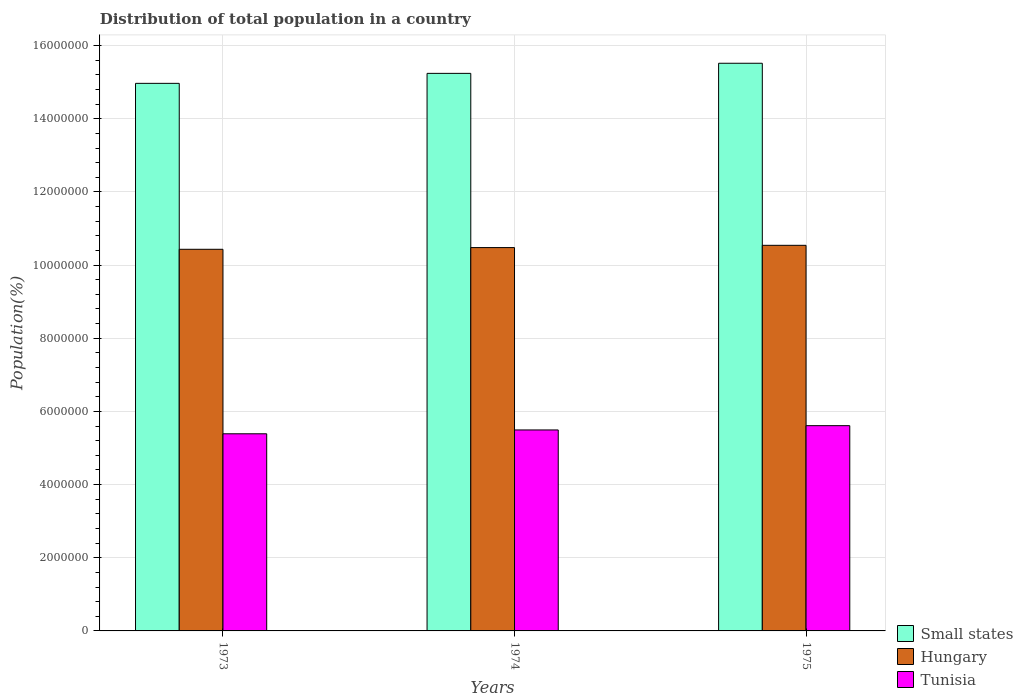Are the number of bars per tick equal to the number of legend labels?
Make the answer very short. Yes. Are the number of bars on each tick of the X-axis equal?
Provide a succinct answer. Yes. How many bars are there on the 3rd tick from the right?
Your answer should be compact. 3. What is the label of the 2nd group of bars from the left?
Make the answer very short. 1974. In how many cases, is the number of bars for a given year not equal to the number of legend labels?
Make the answer very short. 0. What is the population of in Small states in 1975?
Offer a terse response. 1.55e+07. Across all years, what is the maximum population of in Tunisia?
Give a very brief answer. 5.61e+06. Across all years, what is the minimum population of in Hungary?
Your answer should be very brief. 1.04e+07. In which year was the population of in Hungary maximum?
Offer a terse response. 1975. What is the total population of in Small states in the graph?
Your answer should be compact. 4.57e+07. What is the difference between the population of in Tunisia in 1973 and that in 1975?
Your answer should be compact. -2.22e+05. What is the difference between the population of in Hungary in 1973 and the population of in Small states in 1974?
Provide a short and direct response. -4.81e+06. What is the average population of in Hungary per year?
Make the answer very short. 1.05e+07. In the year 1975, what is the difference between the population of in Tunisia and population of in Hungary?
Give a very brief answer. -4.93e+06. What is the ratio of the population of in Tunisia in 1974 to that in 1975?
Your answer should be very brief. 0.98. What is the difference between the highest and the second highest population of in Tunisia?
Provide a succinct answer. 1.17e+05. What is the difference between the highest and the lowest population of in Tunisia?
Make the answer very short. 2.22e+05. What does the 3rd bar from the left in 1973 represents?
Make the answer very short. Tunisia. What does the 2nd bar from the right in 1975 represents?
Offer a very short reply. Hungary. Is it the case that in every year, the sum of the population of in Hungary and population of in Tunisia is greater than the population of in Small states?
Keep it short and to the point. Yes. How many bars are there?
Offer a terse response. 9. Are all the bars in the graph horizontal?
Provide a short and direct response. No. How many years are there in the graph?
Provide a succinct answer. 3. Are the values on the major ticks of Y-axis written in scientific E-notation?
Your answer should be very brief. No. Does the graph contain any zero values?
Provide a short and direct response. No. Does the graph contain grids?
Provide a short and direct response. Yes. How many legend labels are there?
Ensure brevity in your answer.  3. How are the legend labels stacked?
Your answer should be very brief. Vertical. What is the title of the graph?
Make the answer very short. Distribution of total population in a country. What is the label or title of the Y-axis?
Offer a terse response. Population(%). What is the Population(%) of Small states in 1973?
Offer a terse response. 1.50e+07. What is the Population(%) of Hungary in 1973?
Offer a terse response. 1.04e+07. What is the Population(%) of Tunisia in 1973?
Your response must be concise. 5.39e+06. What is the Population(%) of Small states in 1974?
Your answer should be very brief. 1.52e+07. What is the Population(%) in Hungary in 1974?
Your response must be concise. 1.05e+07. What is the Population(%) in Tunisia in 1974?
Ensure brevity in your answer.  5.49e+06. What is the Population(%) in Small states in 1975?
Your answer should be very brief. 1.55e+07. What is the Population(%) of Hungary in 1975?
Offer a very short reply. 1.05e+07. What is the Population(%) in Tunisia in 1975?
Give a very brief answer. 5.61e+06. Across all years, what is the maximum Population(%) of Small states?
Your answer should be compact. 1.55e+07. Across all years, what is the maximum Population(%) in Hungary?
Your answer should be very brief. 1.05e+07. Across all years, what is the maximum Population(%) in Tunisia?
Give a very brief answer. 5.61e+06. Across all years, what is the minimum Population(%) in Small states?
Make the answer very short. 1.50e+07. Across all years, what is the minimum Population(%) of Hungary?
Provide a succinct answer. 1.04e+07. Across all years, what is the minimum Population(%) of Tunisia?
Provide a succinct answer. 5.39e+06. What is the total Population(%) in Small states in the graph?
Give a very brief answer. 4.57e+07. What is the total Population(%) in Hungary in the graph?
Your response must be concise. 3.15e+07. What is the total Population(%) of Tunisia in the graph?
Provide a succinct answer. 1.65e+07. What is the difference between the Population(%) in Small states in 1973 and that in 1974?
Offer a very short reply. -2.73e+05. What is the difference between the Population(%) of Hungary in 1973 and that in 1974?
Make the answer very short. -4.67e+04. What is the difference between the Population(%) of Tunisia in 1973 and that in 1974?
Offer a terse response. -1.05e+05. What is the difference between the Population(%) of Small states in 1973 and that in 1975?
Your answer should be very brief. -5.49e+05. What is the difference between the Population(%) of Hungary in 1973 and that in 1975?
Provide a short and direct response. -1.08e+05. What is the difference between the Population(%) of Tunisia in 1973 and that in 1975?
Your answer should be compact. -2.22e+05. What is the difference between the Population(%) in Small states in 1974 and that in 1975?
Give a very brief answer. -2.76e+05. What is the difference between the Population(%) of Hungary in 1974 and that in 1975?
Make the answer very short. -6.18e+04. What is the difference between the Population(%) of Tunisia in 1974 and that in 1975?
Your answer should be compact. -1.17e+05. What is the difference between the Population(%) of Small states in 1973 and the Population(%) of Hungary in 1974?
Provide a short and direct response. 4.49e+06. What is the difference between the Population(%) of Small states in 1973 and the Population(%) of Tunisia in 1974?
Provide a succinct answer. 9.47e+06. What is the difference between the Population(%) of Hungary in 1973 and the Population(%) of Tunisia in 1974?
Ensure brevity in your answer.  4.94e+06. What is the difference between the Population(%) in Small states in 1973 and the Population(%) in Hungary in 1975?
Give a very brief answer. 4.43e+06. What is the difference between the Population(%) of Small states in 1973 and the Population(%) of Tunisia in 1975?
Ensure brevity in your answer.  9.36e+06. What is the difference between the Population(%) of Hungary in 1973 and the Population(%) of Tunisia in 1975?
Make the answer very short. 4.82e+06. What is the difference between the Population(%) in Small states in 1974 and the Population(%) in Hungary in 1975?
Your answer should be compact. 4.70e+06. What is the difference between the Population(%) of Small states in 1974 and the Population(%) of Tunisia in 1975?
Provide a succinct answer. 9.63e+06. What is the difference between the Population(%) in Hungary in 1974 and the Population(%) in Tunisia in 1975?
Your answer should be compact. 4.87e+06. What is the average Population(%) in Small states per year?
Ensure brevity in your answer.  1.52e+07. What is the average Population(%) in Hungary per year?
Your answer should be compact. 1.05e+07. What is the average Population(%) in Tunisia per year?
Ensure brevity in your answer.  5.50e+06. In the year 1973, what is the difference between the Population(%) of Small states and Population(%) of Hungary?
Your response must be concise. 4.54e+06. In the year 1973, what is the difference between the Population(%) in Small states and Population(%) in Tunisia?
Make the answer very short. 9.58e+06. In the year 1973, what is the difference between the Population(%) of Hungary and Population(%) of Tunisia?
Your answer should be very brief. 5.04e+06. In the year 1974, what is the difference between the Population(%) of Small states and Population(%) of Hungary?
Make the answer very short. 4.76e+06. In the year 1974, what is the difference between the Population(%) of Small states and Population(%) of Tunisia?
Keep it short and to the point. 9.75e+06. In the year 1974, what is the difference between the Population(%) of Hungary and Population(%) of Tunisia?
Make the answer very short. 4.98e+06. In the year 1975, what is the difference between the Population(%) in Small states and Population(%) in Hungary?
Your answer should be compact. 4.98e+06. In the year 1975, what is the difference between the Population(%) of Small states and Population(%) of Tunisia?
Provide a short and direct response. 9.91e+06. In the year 1975, what is the difference between the Population(%) in Hungary and Population(%) in Tunisia?
Your answer should be compact. 4.93e+06. What is the ratio of the Population(%) of Small states in 1973 to that in 1974?
Ensure brevity in your answer.  0.98. What is the ratio of the Population(%) in Hungary in 1973 to that in 1974?
Keep it short and to the point. 1. What is the ratio of the Population(%) of Tunisia in 1973 to that in 1974?
Your answer should be very brief. 0.98. What is the ratio of the Population(%) of Small states in 1973 to that in 1975?
Provide a succinct answer. 0.96. What is the ratio of the Population(%) in Hungary in 1973 to that in 1975?
Keep it short and to the point. 0.99. What is the ratio of the Population(%) of Tunisia in 1973 to that in 1975?
Make the answer very short. 0.96. What is the ratio of the Population(%) in Small states in 1974 to that in 1975?
Ensure brevity in your answer.  0.98. What is the ratio of the Population(%) of Hungary in 1974 to that in 1975?
Ensure brevity in your answer.  0.99. What is the ratio of the Population(%) in Tunisia in 1974 to that in 1975?
Keep it short and to the point. 0.98. What is the difference between the highest and the second highest Population(%) in Small states?
Ensure brevity in your answer.  2.76e+05. What is the difference between the highest and the second highest Population(%) in Hungary?
Keep it short and to the point. 6.18e+04. What is the difference between the highest and the second highest Population(%) in Tunisia?
Your answer should be compact. 1.17e+05. What is the difference between the highest and the lowest Population(%) of Small states?
Keep it short and to the point. 5.49e+05. What is the difference between the highest and the lowest Population(%) of Hungary?
Keep it short and to the point. 1.08e+05. What is the difference between the highest and the lowest Population(%) in Tunisia?
Give a very brief answer. 2.22e+05. 